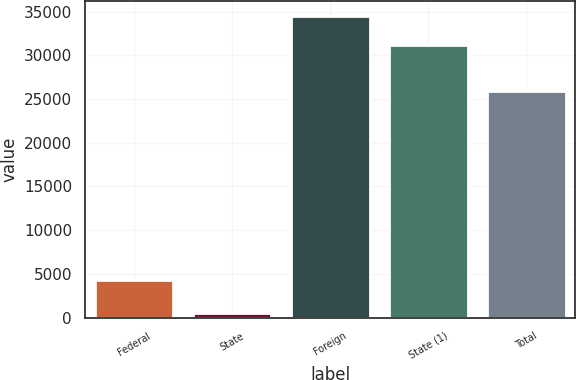Convert chart to OTSL. <chart><loc_0><loc_0><loc_500><loc_500><bar_chart><fcel>Federal<fcel>State<fcel>Foreign<fcel>State (1)<fcel>Total<nl><fcel>4285<fcel>541<fcel>34509.5<fcel>31229<fcel>25983<nl></chart> 